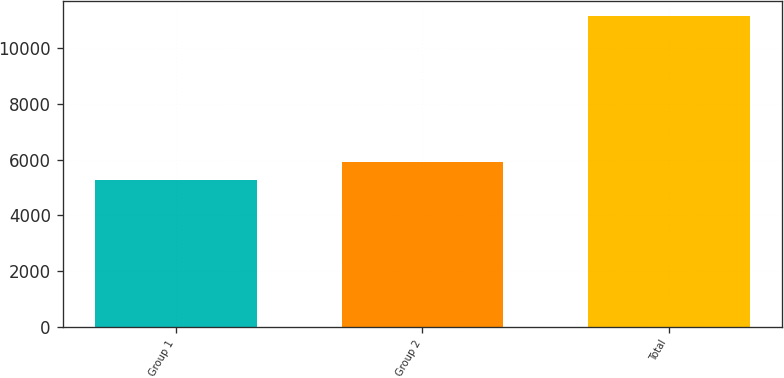Convert chart to OTSL. <chart><loc_0><loc_0><loc_500><loc_500><bar_chart><fcel>Group 1<fcel>Group 2<fcel>Total<nl><fcel>5258.2<fcel>5905<fcel>11163.2<nl></chart> 